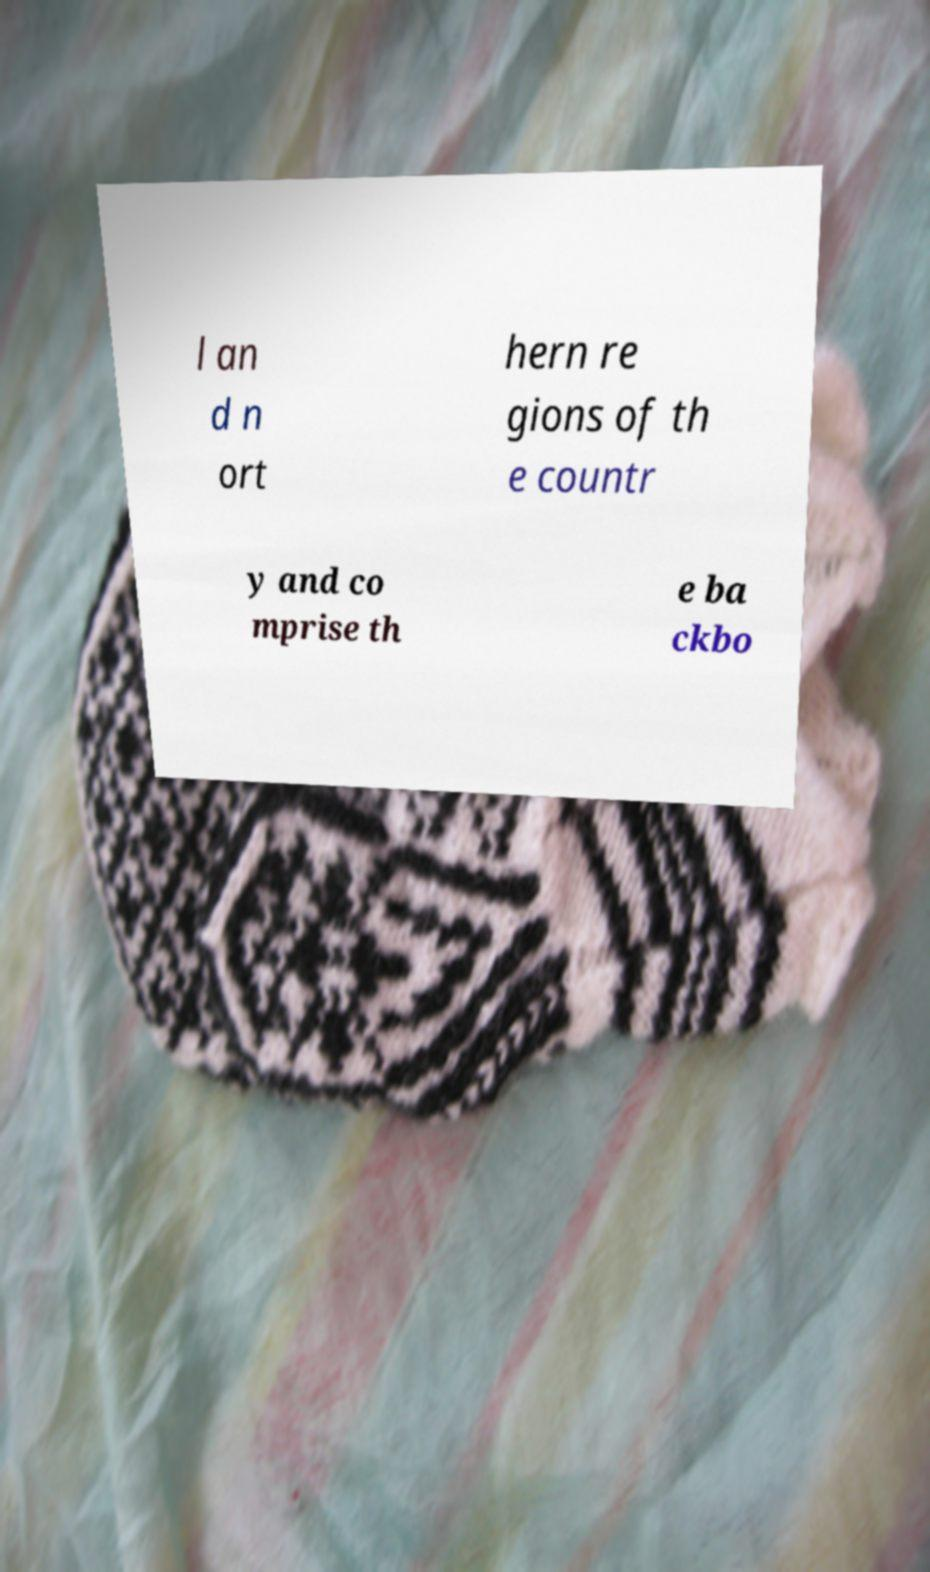Please identify and transcribe the text found in this image. l an d n ort hern re gions of th e countr y and co mprise th e ba ckbo 